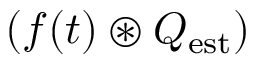<formula> <loc_0><loc_0><loc_500><loc_500>( f ( t ) \circledast Q _ { e s t } )</formula> 